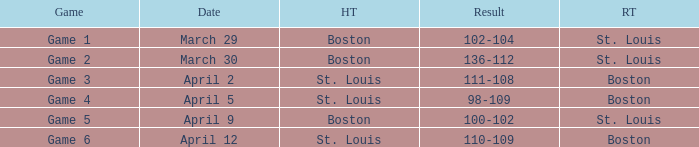What is the Game number on March 30? Game 2. 